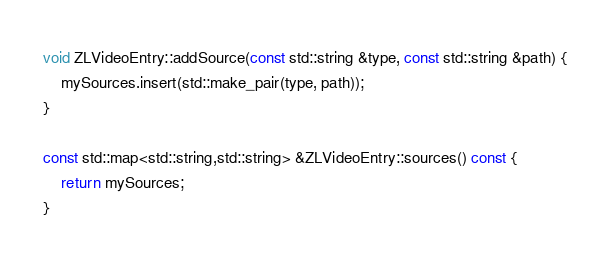Convert code to text. <code><loc_0><loc_0><loc_500><loc_500><_C++_>void ZLVideoEntry::addSource(const std::string &type, const std::string &path) {
	mySources.insert(std::make_pair(type, path));
}

const std::map<std::string,std::string> &ZLVideoEntry::sources() const {
	return mySources;
}
</code> 